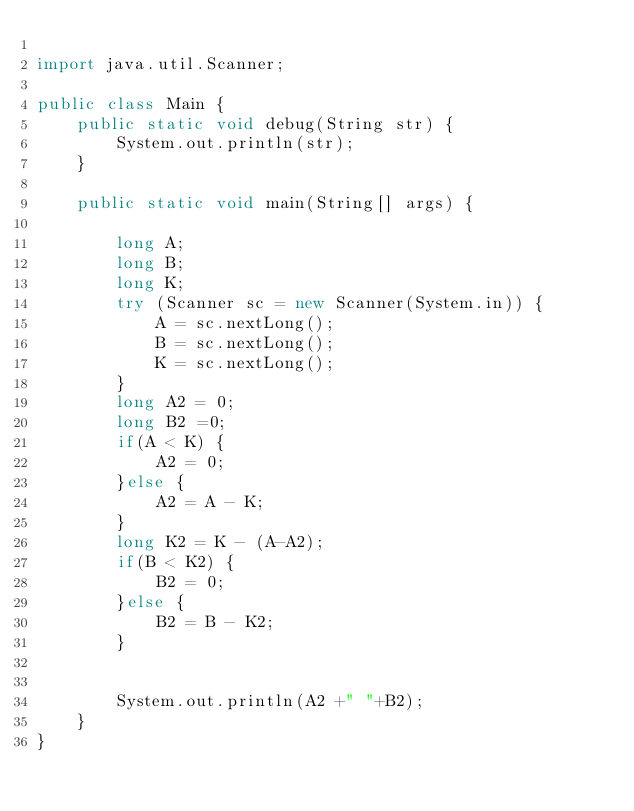Convert code to text. <code><loc_0><loc_0><loc_500><loc_500><_Java_>
import java.util.Scanner;

public class Main {
    public static void debug(String str) {
        System.out.println(str);
    }

    public static void main(String[] args) {

        long A;
        long B;
        long K;
        try (Scanner sc = new Scanner(System.in)) {
            A = sc.nextLong();
            B = sc.nextLong();
            K = sc.nextLong();
        }
        long A2 = 0;
        long B2 =0;
        if(A < K) {
            A2 = 0;
        }else {
            A2 = A - K;
        }
        long K2 = K - (A-A2);
        if(B < K2) {
            B2 = 0;
        }else {
            B2 = B - K2;
        }


        System.out.println(A2 +" "+B2);
    }
}
</code> 